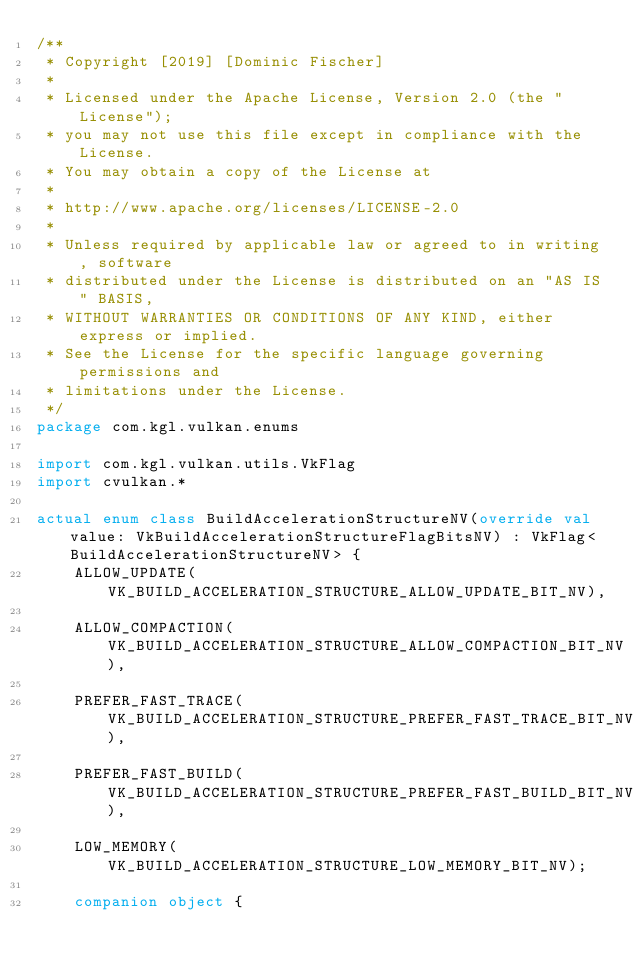Convert code to text. <code><loc_0><loc_0><loc_500><loc_500><_Kotlin_>/**
 * Copyright [2019] [Dominic Fischer]
 *
 * Licensed under the Apache License, Version 2.0 (the "License");
 * you may not use this file except in compliance with the License.
 * You may obtain a copy of the License at
 *
 * http://www.apache.org/licenses/LICENSE-2.0
 *
 * Unless required by applicable law or agreed to in writing, software
 * distributed under the License is distributed on an "AS IS" BASIS,
 * WITHOUT WARRANTIES OR CONDITIONS OF ANY KIND, either express or implied.
 * See the License for the specific language governing permissions and
 * limitations under the License.
 */
package com.kgl.vulkan.enums

import com.kgl.vulkan.utils.VkFlag
import cvulkan.*

actual enum class BuildAccelerationStructureNV(override val value: VkBuildAccelerationStructureFlagBitsNV) : VkFlag<BuildAccelerationStructureNV> {
	ALLOW_UPDATE(VK_BUILD_ACCELERATION_STRUCTURE_ALLOW_UPDATE_BIT_NV),

	ALLOW_COMPACTION(VK_BUILD_ACCELERATION_STRUCTURE_ALLOW_COMPACTION_BIT_NV),

	PREFER_FAST_TRACE(VK_BUILD_ACCELERATION_STRUCTURE_PREFER_FAST_TRACE_BIT_NV),

	PREFER_FAST_BUILD(VK_BUILD_ACCELERATION_STRUCTURE_PREFER_FAST_BUILD_BIT_NV),

	LOW_MEMORY(VK_BUILD_ACCELERATION_STRUCTURE_LOW_MEMORY_BIT_NV);

	companion object {</code> 